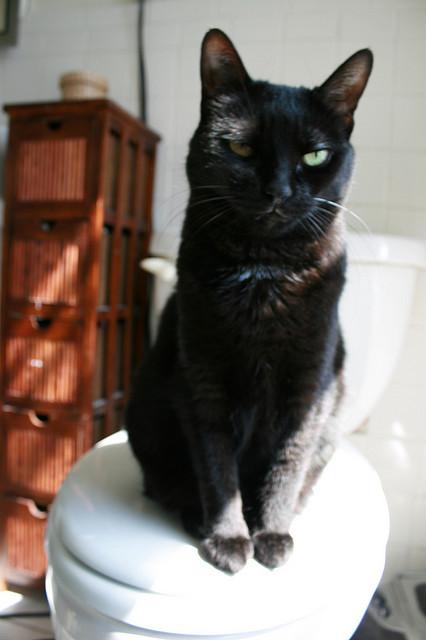What is the cat sitting on?
Be succinct. Toilet. Does the cat look nice?
Keep it brief. Yes. What color is the cat?
Answer briefly. Black. 